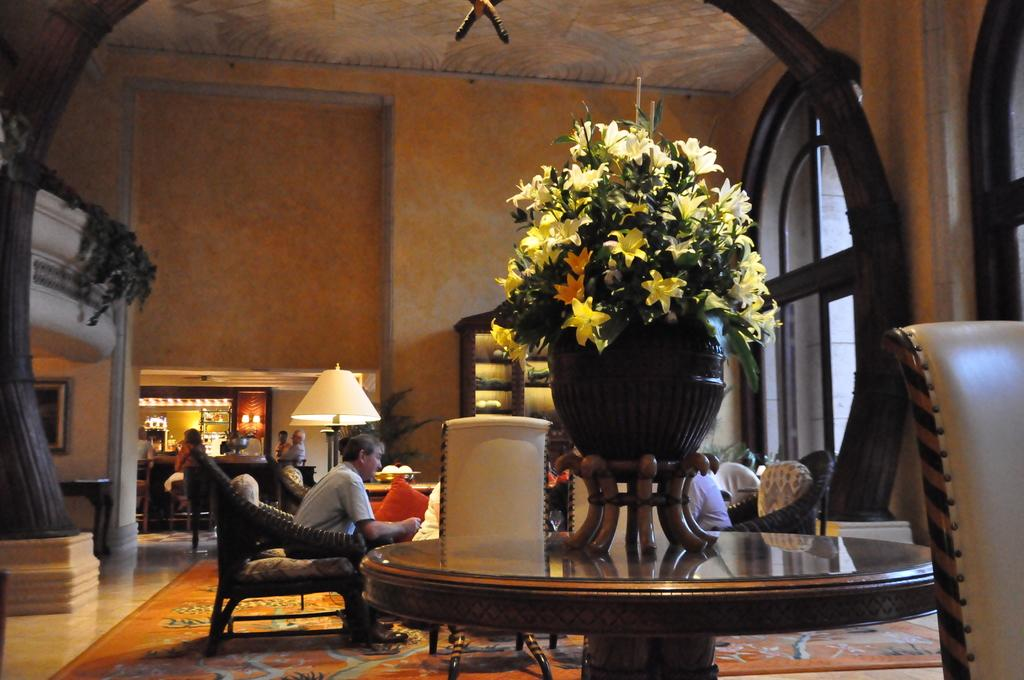What is on the table in the image? There is a flower vase on the table. What can be seen in the background of the image? People are sitting on chairs in the background. What is another object visible in the image? There is a lamp in the image. Is there any storage or display space visible in the image? Yes, there is a shelf in the image. What type of news is being discussed by the people sitting on chairs in the image? There is no indication in the image that the people are discussing any news, as the focus is on the objects and their arrangement. 